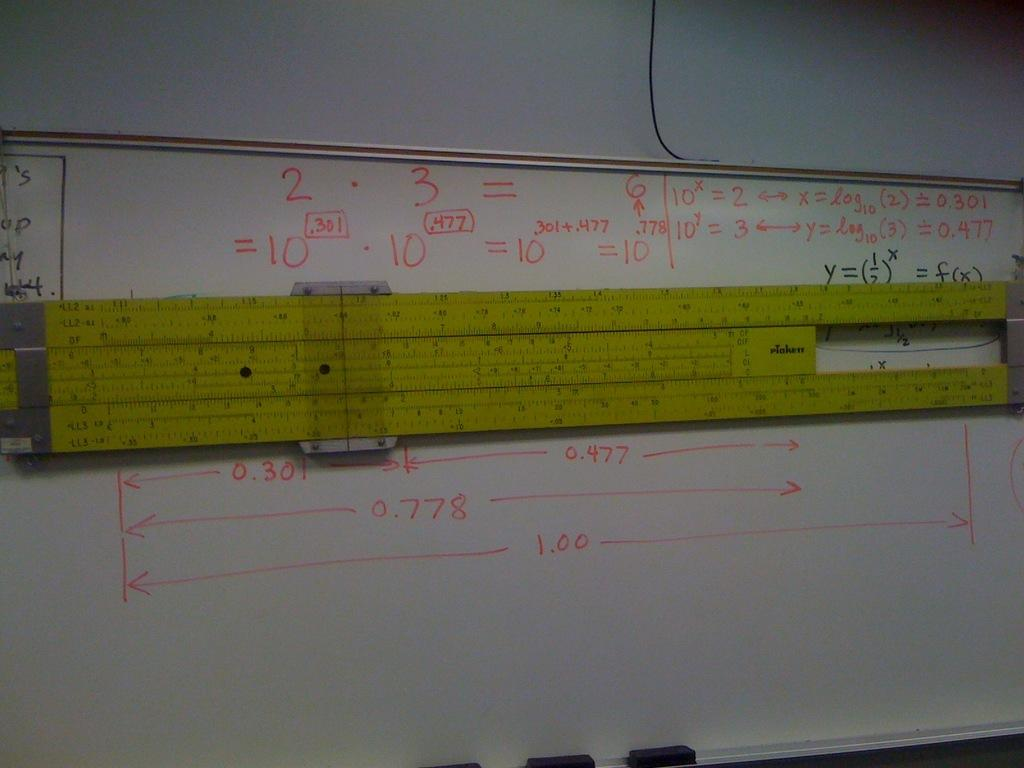<image>
Render a clear and concise summary of the photo. Whiteboard that has rulers on it and red numbers that say 1.00 